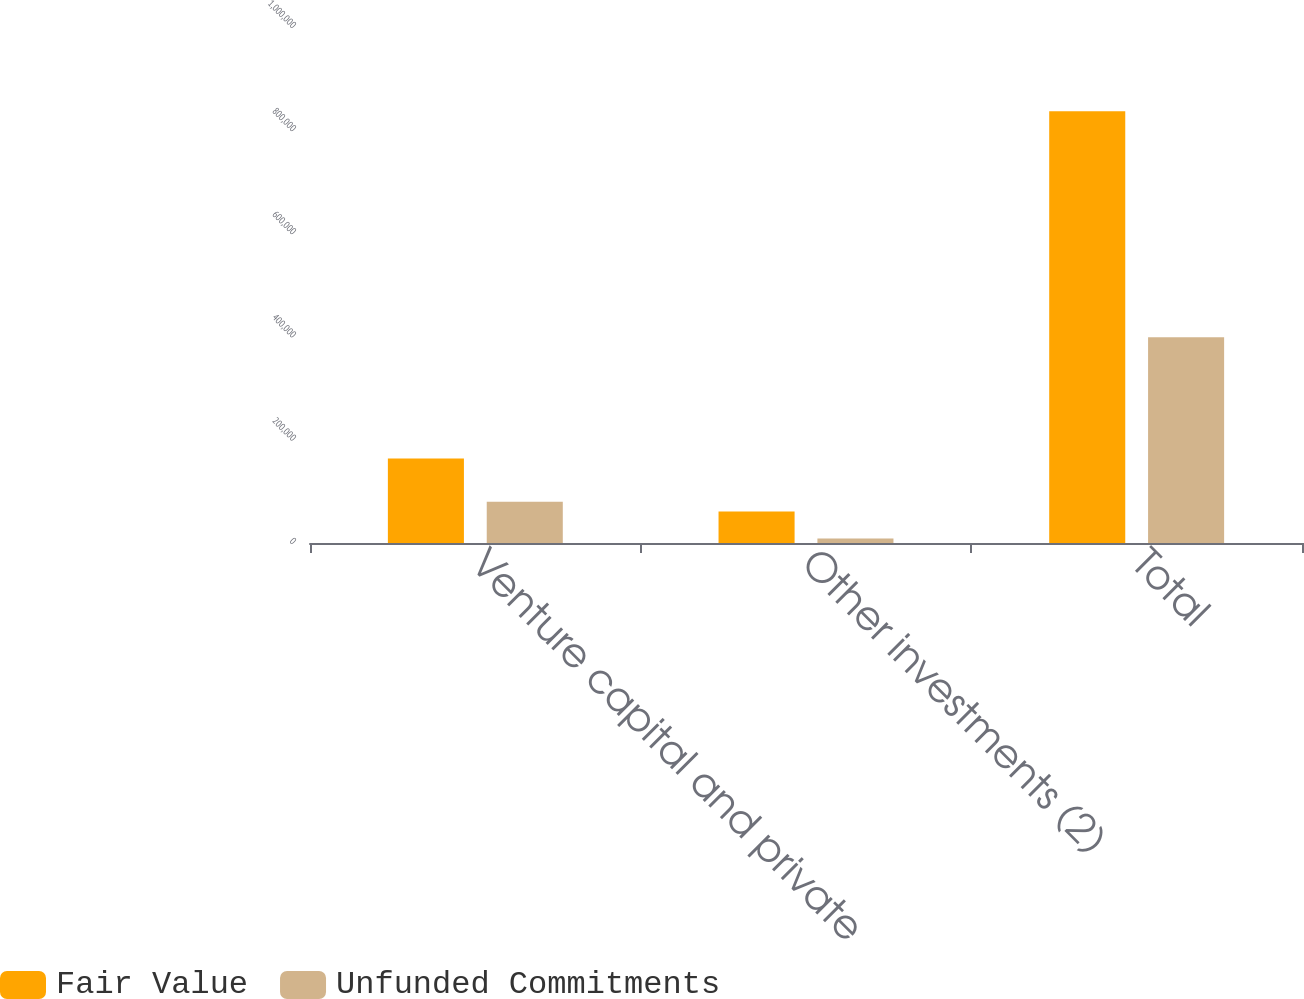Convert chart. <chart><loc_0><loc_0><loc_500><loc_500><stacked_bar_chart><ecel><fcel>Venture capital and private<fcel>Other investments (2)<fcel>Total<nl><fcel>Fair Value<fcel>163674<fcel>61227<fcel>836725<nl><fcel>Unfunded Commitments<fcel>80010<fcel>8750<fcel>398525<nl></chart> 